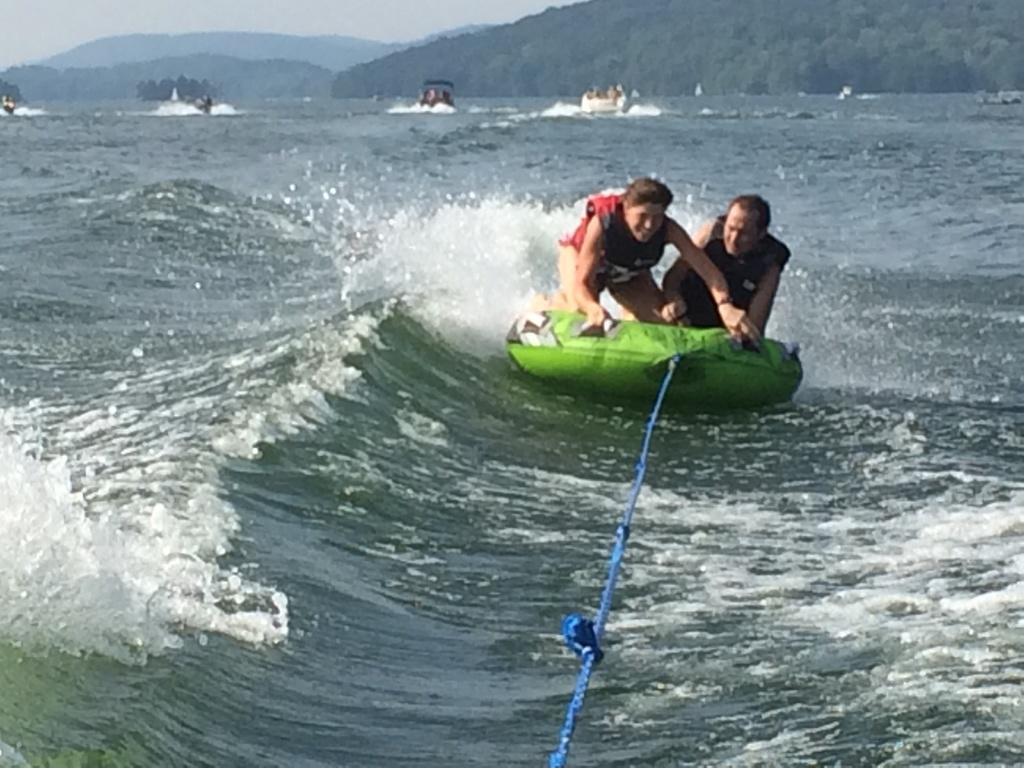Could you give a brief overview of what you see in this image? This is an ocean. Here I can see two people are surfing the board on the water. I can see a blue color rope is attached to this board. In the background, I can see four boats on the water and also there are some hills. On the top of the image I can see the sky. 